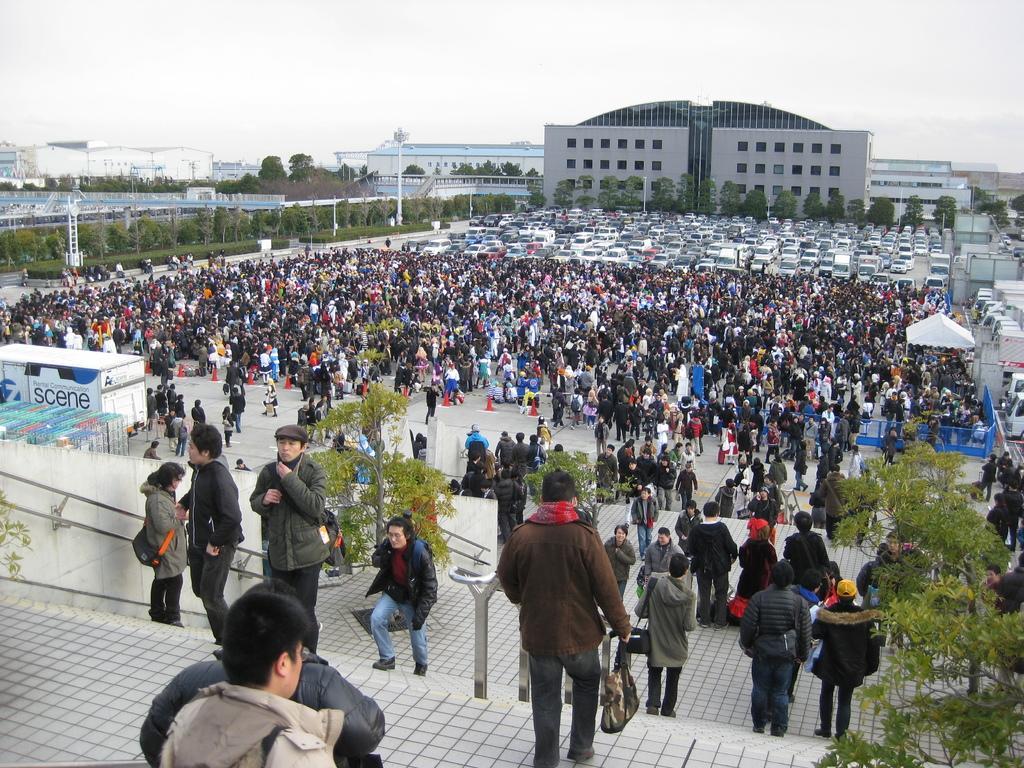How would you summarize this image in a sentence or two? In this image few persons are standing on the floor. Few persons are walking on the stairs. Right bottom there is a tree. A person wearing a brown jacket is holding a bag in his hand. Left side a person standing on the stairs is carrying a bag. Behind the persons there are few cars and trees. Left side there are few poles. Behind there are few plants and trees. Background there are few buildings. Top of image there is sky. Right side there are few vehicles beside the fence. 